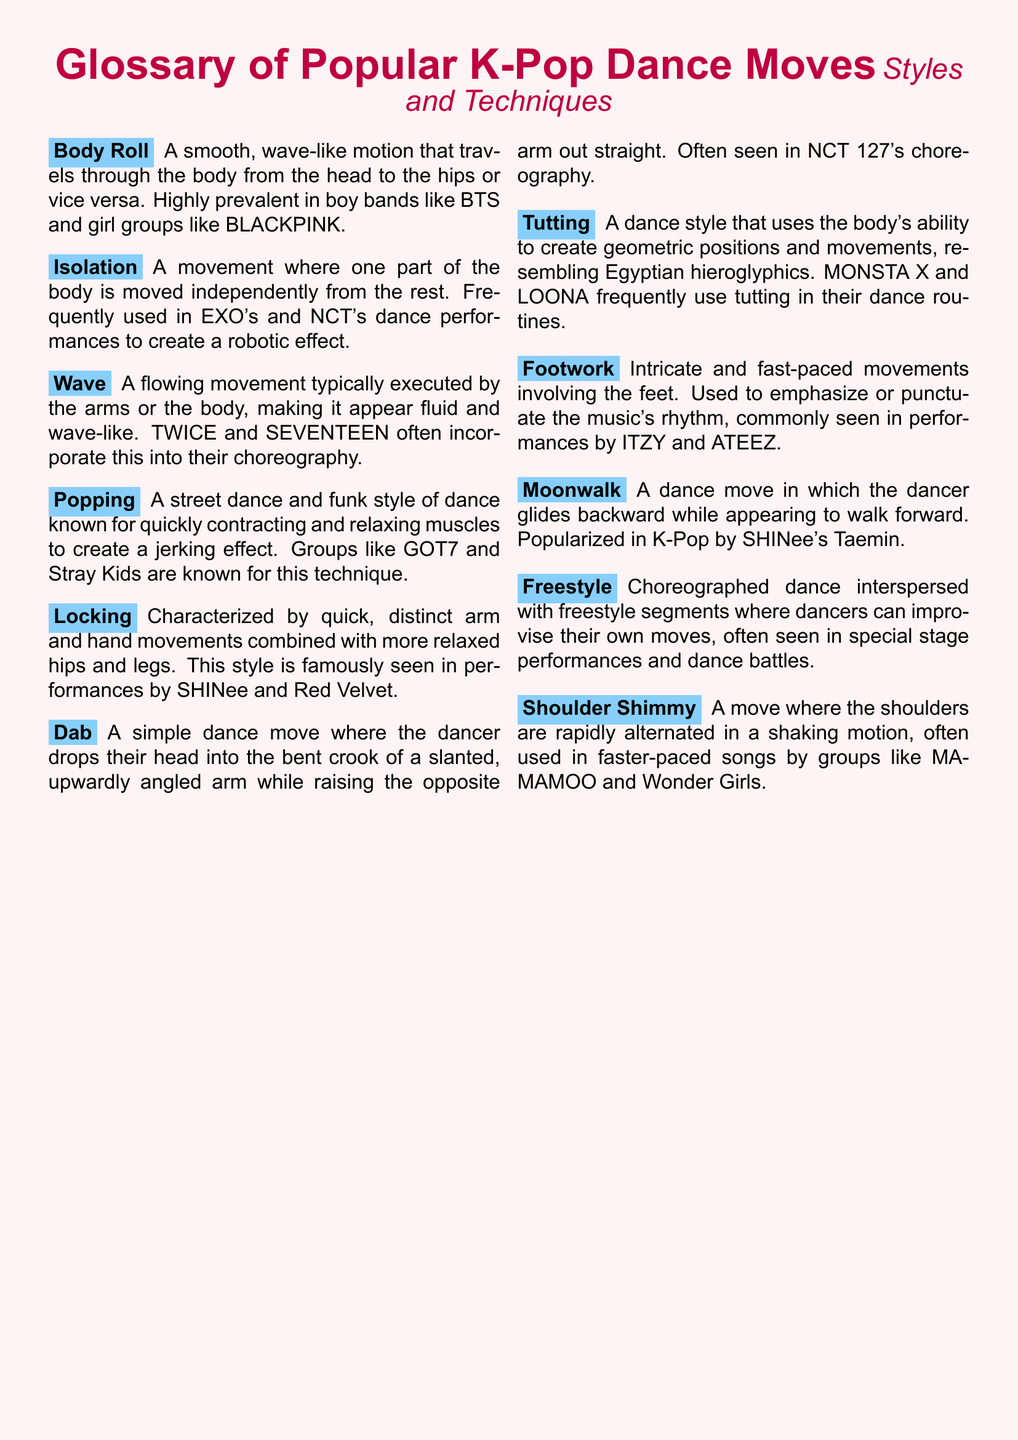What is the dance move characterized by a smooth, wave-like motion? The dance move with a wave-like motion is known as a Body Roll.
Answer: Body Roll Which K-Pop group is known for using the Locking style? Locking is famously seen in performances by SHINee and Red Velvet.
Answer: SHINee and Red Velvet What technique involves rapid shoulder movements? The technique involving rapid shoulder movements is called the Shoulder Shimmy.
Answer: Shoulder Shimmy What is the dance style that resembles Egyptian hieroglyphics? The dance style that resembles Egyptian hieroglyphics is Tutting.
Answer: Tutting How is the Dab dance move executed? The Dab involves dropping the head into the bent crook of a slanted arm and raising the opposite arm.
Answer: Dropping the head into the bent crook of a slanted arm Which K-Pop group popularized the Moonwalk? The Moonwalk was popularized in K-Pop by SHINee's Taemin.
Answer: Taemin What type of dance incorporates freestyle segments? Freestyle dance involves choreographed segments mixed with improvisation.
Answer: Freestyle Which dance move creates a jerking effect through muscle contractions? The dance move that creates a jerking effect through muscle contractions is Popping.
Answer: Popping Which K-Pop groups are known for using Footwork in their performances? Footwork is commonly seen in performances by ITZY and ATEEZ.
Answer: ITZY and ATEEZ 